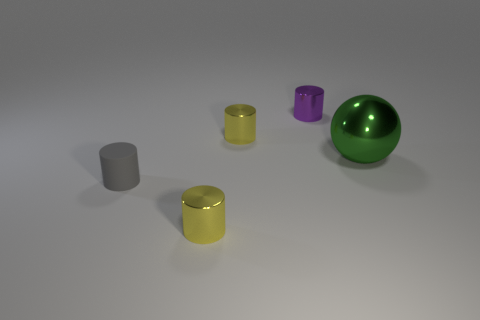Subtract all blue cylinders. Subtract all yellow cubes. How many cylinders are left? 4 Add 1 shiny balls. How many objects exist? 6 Subtract all cylinders. How many objects are left? 1 Subtract all green shiny cubes. Subtract all small yellow objects. How many objects are left? 3 Add 4 tiny matte things. How many tiny matte things are left? 5 Add 3 small metallic cylinders. How many small metallic cylinders exist? 6 Subtract 0 yellow balls. How many objects are left? 5 